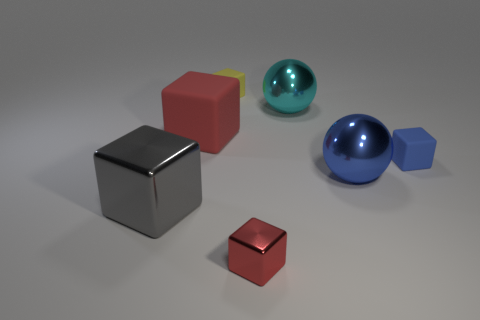What size is the thing that is both in front of the tiny yellow thing and behind the large matte object?
Keep it short and to the point. Large. What number of other objects are the same material as the big gray block?
Offer a terse response. 3. What size is the matte block that is on the right side of the tiny yellow matte object?
Your answer should be very brief. Small. Is the color of the big matte object the same as the small metal block?
Your response must be concise. Yes. What number of small things are either blue rubber blocks or blue cylinders?
Your answer should be very brief. 1. Are there any other things that are the same color as the big shiny cube?
Ensure brevity in your answer.  No. Are there any big red objects on the left side of the cyan ball?
Offer a terse response. Yes. There is a red block that is behind the small rubber block in front of the large cyan metallic ball; how big is it?
Provide a succinct answer. Large. Is the number of shiny spheres that are behind the cyan metal thing the same as the number of small blue matte blocks on the right side of the small red metal thing?
Your response must be concise. No. There is a small cube that is left of the small red shiny thing; is there a yellow rubber block that is in front of it?
Keep it short and to the point. No. 